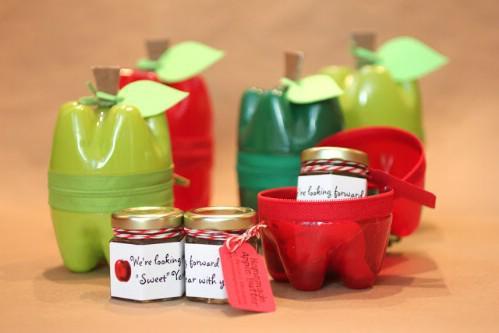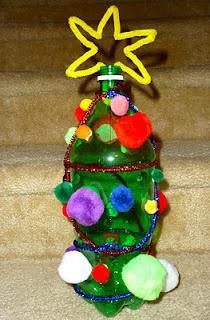The first image is the image on the left, the second image is the image on the right. For the images shown, is this caption "In one of the images, the plastic bottles have been remade into containers that look like apples." true? Answer yes or no. Yes. The first image is the image on the left, the second image is the image on the right. Assess this claim about the two images: "The right image shows something holding a green bottle horizontally with its top end to the right.". Correct or not? Answer yes or no. No. 